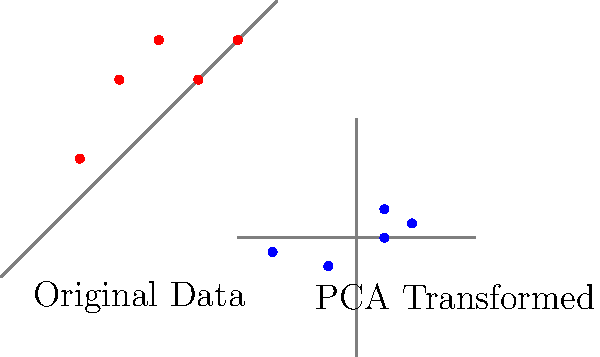In the context of dimensionality reduction, what is the primary advantage of using Principal Component Analysis (PCA) as visualized in the plot? To understand the advantage of PCA in dimensionality reduction, let's analyze the plot step-by-step:

1. Original Data:
   - The left plot shows the original data points in red.
   - These points are scattered in a 2D space, showing some correlation between x and y.

2. PCA Transformed Data:
   - The right plot shows the same data points after PCA transformation in blue.
   - The transformed points are now aligned along the x-axis, with minimal variation along the y-axis.

3. Dimensionality Reduction:
   - In the original data, we needed both x and y coordinates to represent each point.
   - After PCA, most of the variation is captured along the x-axis (first principal component).
   - The y-axis (second principal component) contributes minimally to the data's overall variance.

4. Data Compression:
   - If we were to reduce dimensionality, we could potentially represent the data using only the x-coordinates of the transformed points.
   - This would reduce the data from 2D to 1D while retaining most of the important information.

5. Variance Maximization:
   - PCA has rotated the data so that the direction of maximum variance aligns with the x-axis.
   - This allows us to easily identify and retain the most important features of the data.

6. Noise Reduction:
   - The minimal variation along the y-axis in the transformed data might represent noise or less important features.
   - By focusing on the first principal component (x-axis), we can potentially reduce noise in our dataset.

The primary advantage of PCA, as visualized here, is its ability to identify the directions (principal components) that capture the maximum variance in the data. This allows for effective dimensionality reduction while preserving the most important features of the dataset.
Answer: Maximizes variance along fewer dimensions, enabling efficient dimensionality reduction. 